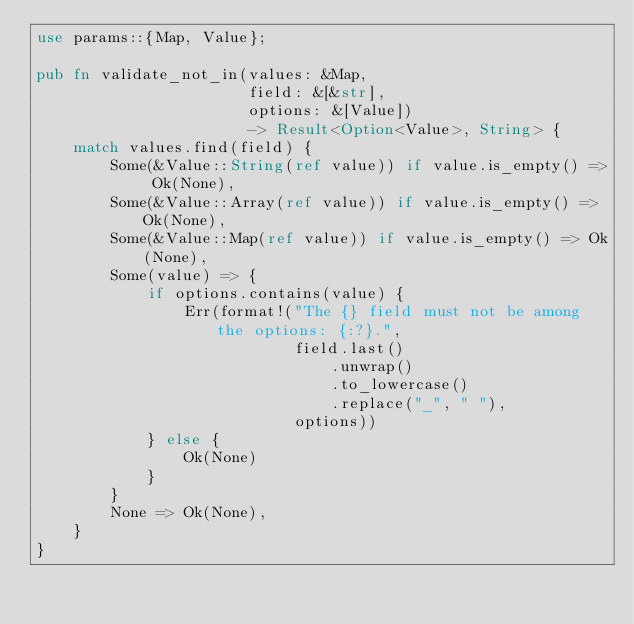Convert code to text. <code><loc_0><loc_0><loc_500><loc_500><_Rust_>use params::{Map, Value};

pub fn validate_not_in(values: &Map,
                       field: &[&str],
                       options: &[Value])
                       -> Result<Option<Value>, String> {
    match values.find(field) {
        Some(&Value::String(ref value)) if value.is_empty() => Ok(None),
        Some(&Value::Array(ref value)) if value.is_empty() => Ok(None),
        Some(&Value::Map(ref value)) if value.is_empty() => Ok(None),
        Some(value) => {
            if options.contains(value) {
                Err(format!("The {} field must not be among the options: {:?}.",
                            field.last()
                                .unwrap()
                                .to_lowercase()
                                .replace("_", " "),
                            options))
            } else {
                Ok(None)
            }
        }
        None => Ok(None),
    }
}
</code> 